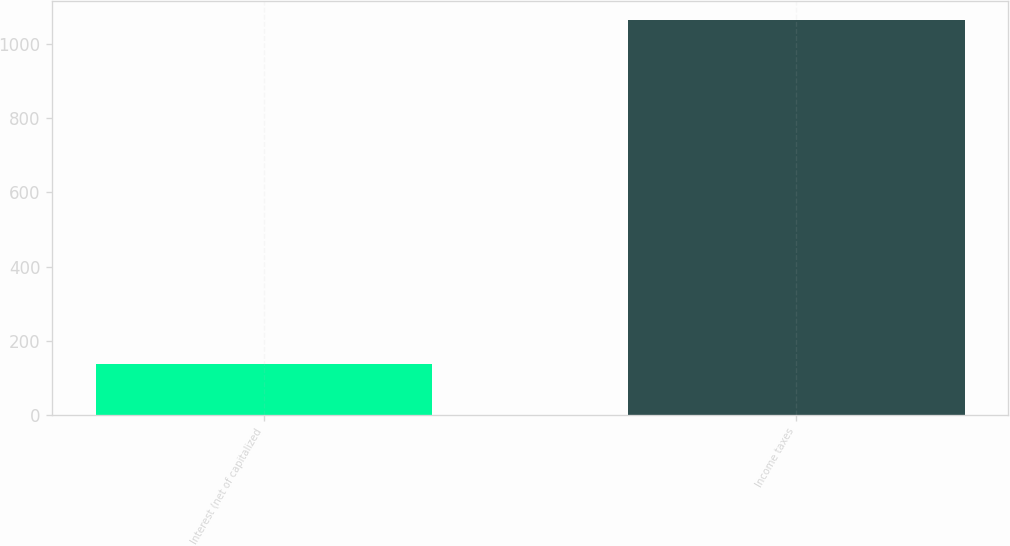<chart> <loc_0><loc_0><loc_500><loc_500><bar_chart><fcel>Interest (net of capitalized<fcel>Income taxes<nl><fcel>136<fcel>1064<nl></chart> 